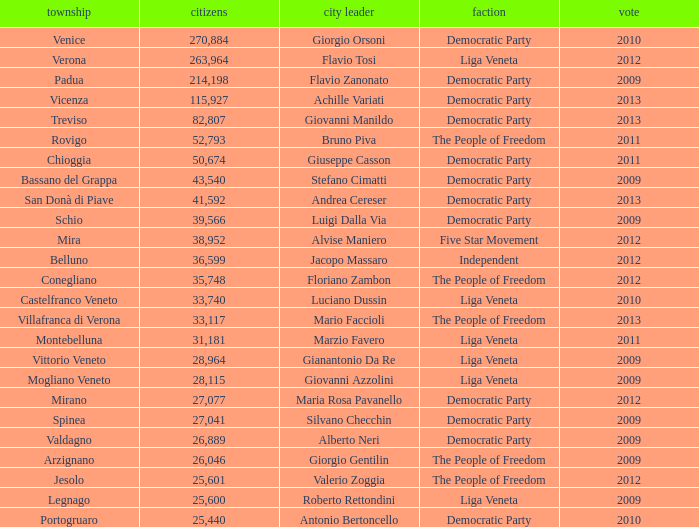In the election earlier than 2012 how many Inhabitants had a Party of five star movement? None. 